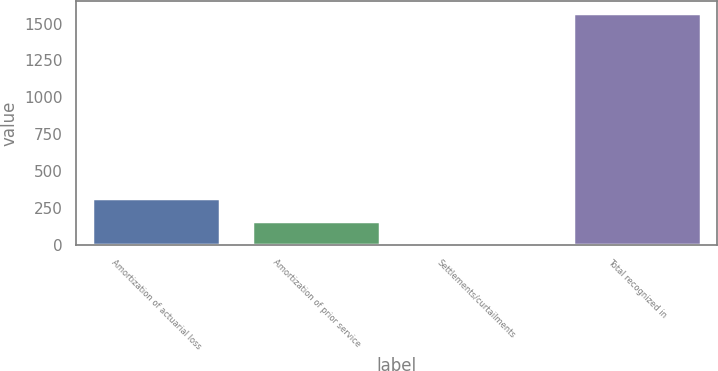Convert chart. <chart><loc_0><loc_0><loc_500><loc_500><bar_chart><fcel>Amortization of actuarial loss<fcel>Amortization of prior service<fcel>Settlements/curtailments<fcel>Total recognized in<nl><fcel>316.2<fcel>159.1<fcel>2<fcel>1573<nl></chart> 